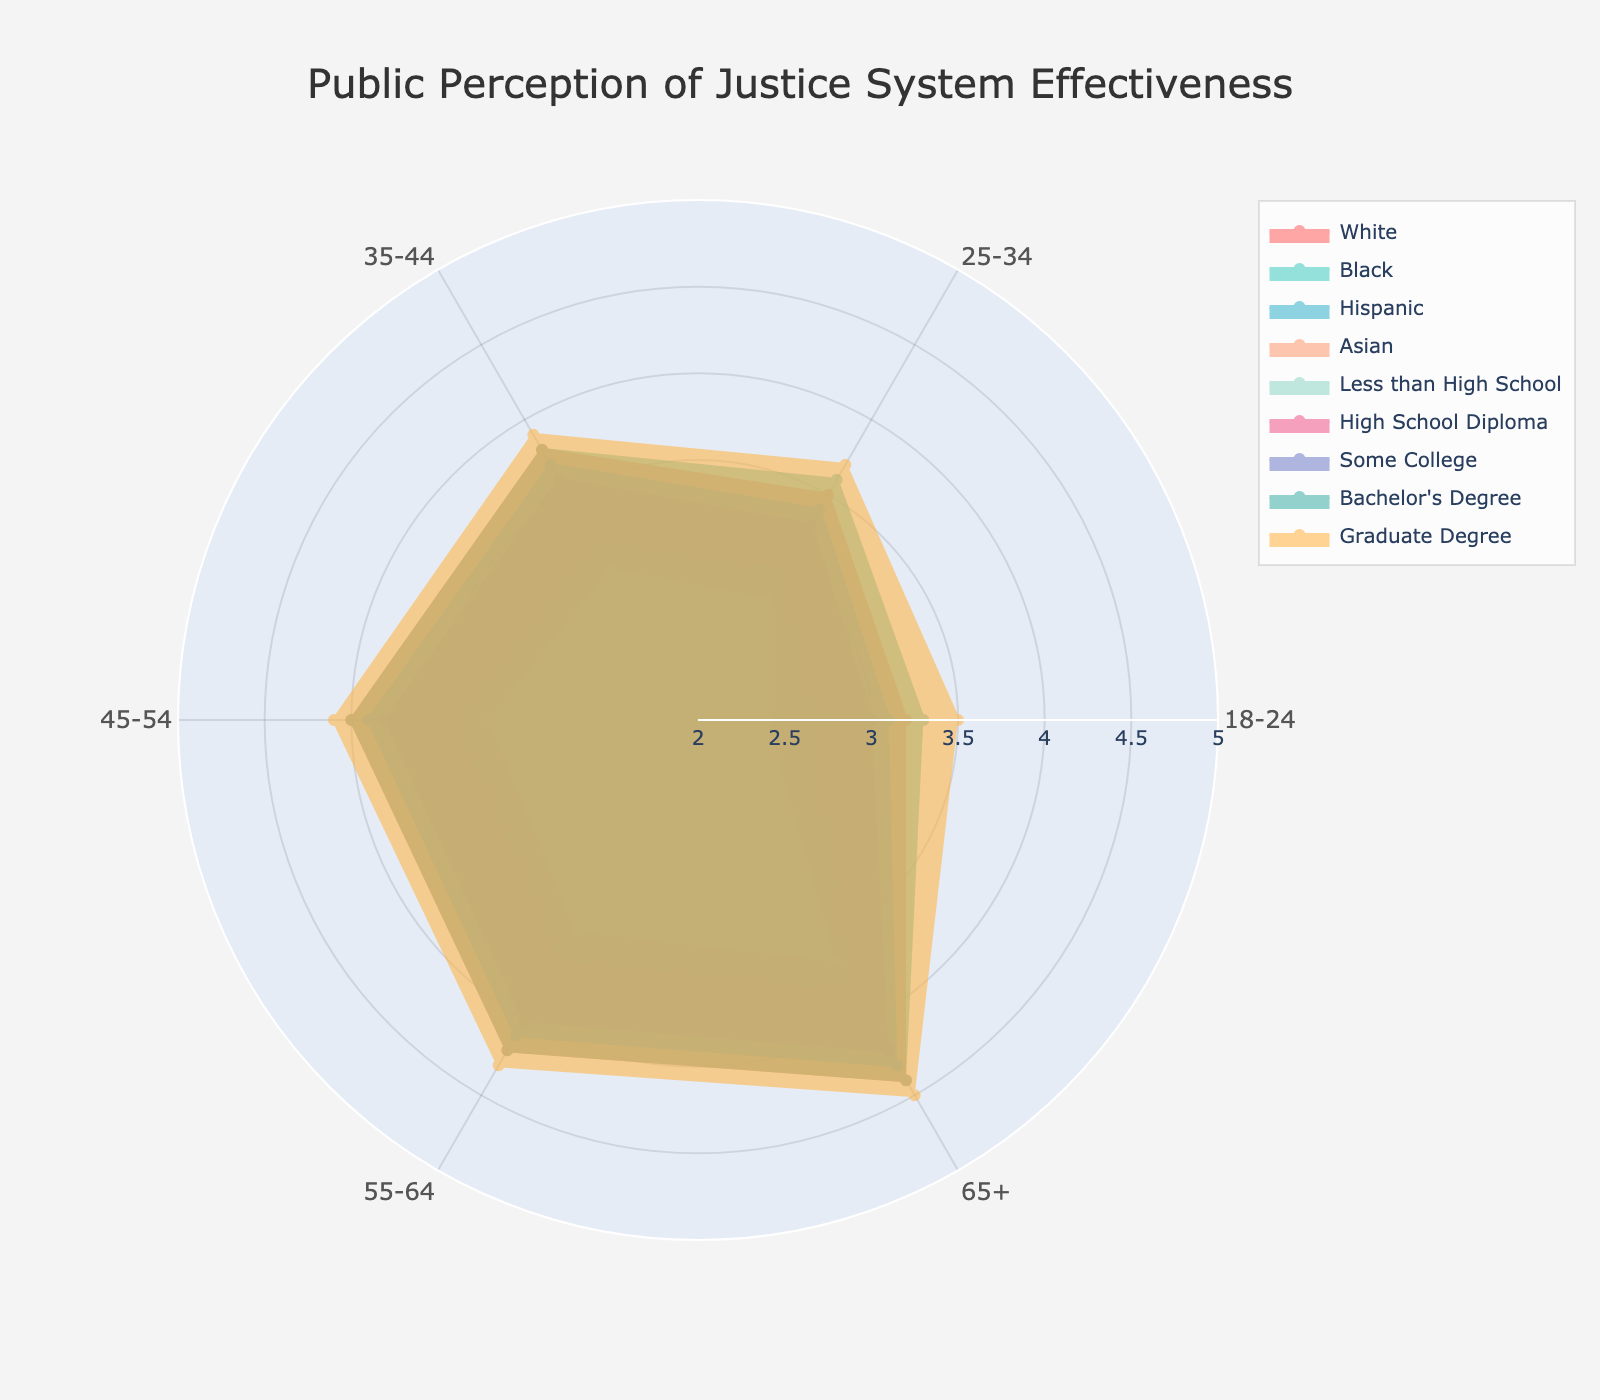What is the title of the radar chart? The title is typically displayed at the top center of the radar chart. The title of this radar chart is "Public Perception of Justice System Effectiveness."
Answer: Public Perception of Justice System Effectiveness Which age group reports the highest perception of justice system effectiveness across all demographics? To find the highest perception of justice system effectiveness across all demographics, we look for the maximum value in all categories. The 65+ age group reports the highest values, especially among individuals with a Graduate Degree (4.5).
Answer: 65+ Among the racial groups, which has the lowest perception of the justice system in the 18-24 age range? Comparing the values for each racial group in the 18-24 age range, the lowest score is 2.5 for the Hispanic group.
Answer: Hispanic How does the perception of the justice system effectiveness differ between Whites and Blacks in the 45-54 age range? Looking at the corresponding values in the 45-54 age range, Whites have a perception score of 4.0, while Blacks have a perception score of 3.4. The difference is 4.0 - 3.4 = 0.6.
Answer: 0.6 What is the average perception score of the justice system for Asians across all age groups? Sum up the scores for Asians across all age groups (3.0 + 3.2 + 3.4 + 3.6 + 3.8 + 4.0) and divide by the number of age groups (6). The total is 21 divided by 6, giving an average of 3.5.
Answer: 3.5 Which education level shows the most substantial increase in perception from the 18-24 to 65+ age group? We need to subtract the value of each education level at 18-24 from its value at 65+ and find the highest difference. The differences are: Less than High School (3.6 - 2.4 = 1.2), High School Diploma (4.2 - 3.0 = 1.2), Some College (4.3 - 3.1 = 1.2), Bachelor's Degree (4.4 - 3.3 = 1.1), Graduate Degree (4.5 - 3.5 = 1.0). All show the same substantial increase of 1.2 except for Bachelor's Degree and Graduate Degree.
Answer: Less than High School, High School Diploma, Some College What is the highest perception score among individuals with a Graduate Degree, and at which age group does it occur? The highest score for individuals with a Graduate Degree is recorded at the 65+ age group, with a value of 4.5.
Answer: 4.5 at 65+ Compare the perception of justice system effectiveness between Hispanics and Asians in the 35-44 age range. Is it higher or lower for Asians? Look at the values for Hispanics and Asians in the 35-44 age range. Hispanics rate it 3.0, and Asians rate it 3.4. Asians' perception is higher by 0.4.
Answer: Higher, by 0.4 What is the overall trend in perception of justice system effectiveness as the age group increases for the demographic of individuals with a High School Diploma? Observing the values for individuals with a High School Diploma across increasing age groups (3.0, 3.3, 3.6, 3.8, 4.0, 4.2), we notice that the perception score steadily increases.
Answer: Increasing trend 